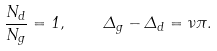<formula> <loc_0><loc_0><loc_500><loc_500>\frac { N _ { d } } { N _ { g } } = 1 , \quad \Delta _ { g } - \Delta _ { d } = \nu \pi .</formula> 